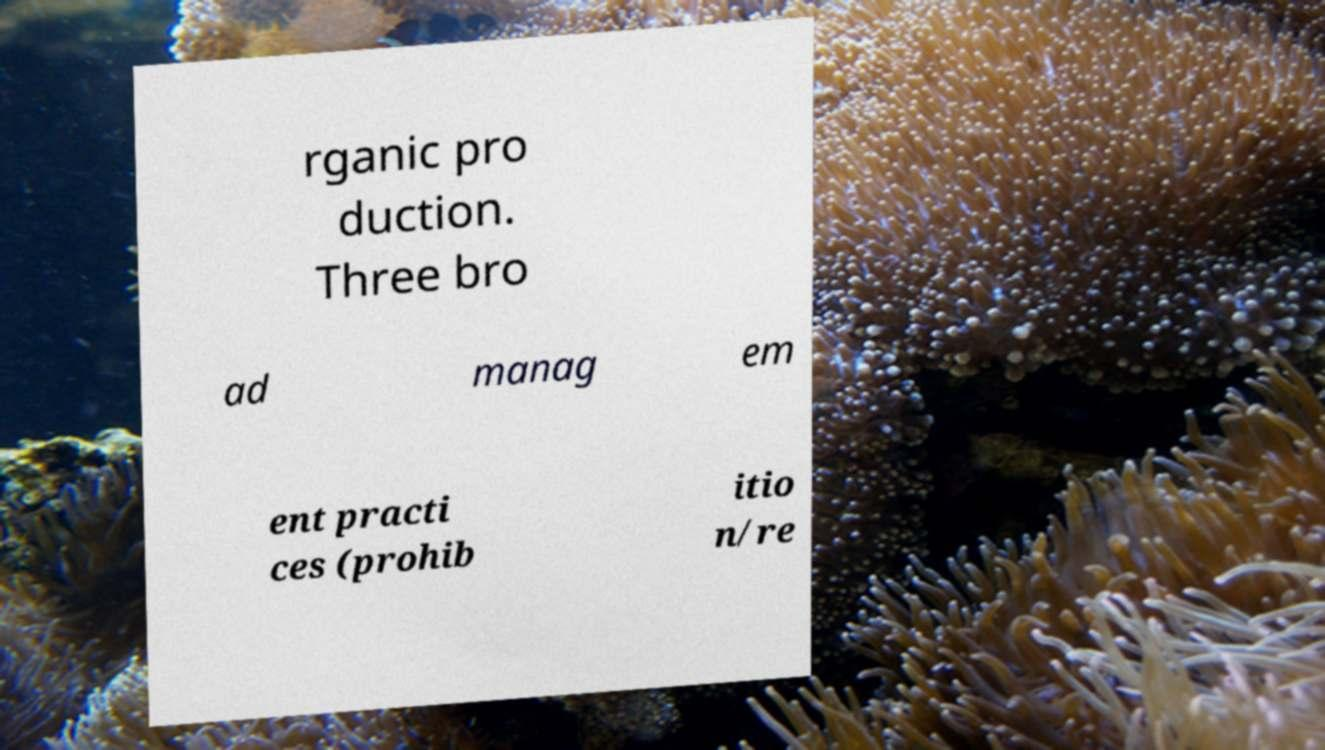I need the written content from this picture converted into text. Can you do that? rganic pro duction. Three bro ad manag em ent practi ces (prohib itio n/re 